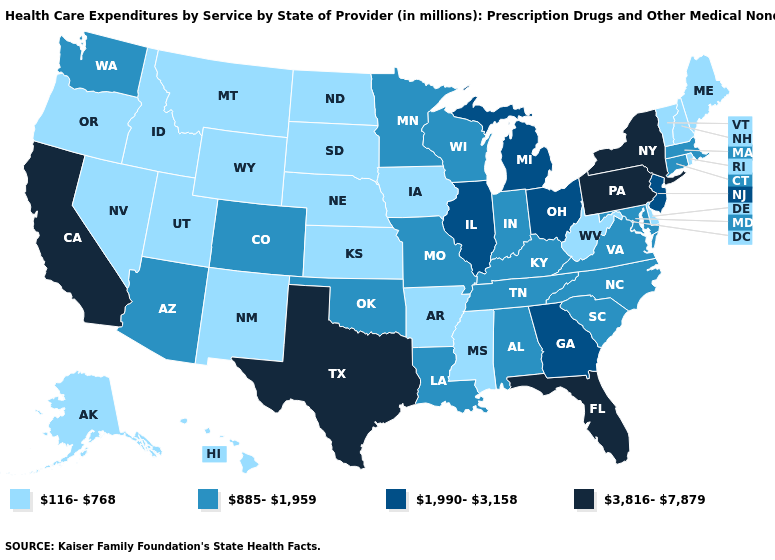What is the value of Connecticut?
Short answer required. 885-1,959. What is the lowest value in the South?
Short answer required. 116-768. Name the states that have a value in the range 116-768?
Answer briefly. Alaska, Arkansas, Delaware, Hawaii, Idaho, Iowa, Kansas, Maine, Mississippi, Montana, Nebraska, Nevada, New Hampshire, New Mexico, North Dakota, Oregon, Rhode Island, South Dakota, Utah, Vermont, West Virginia, Wyoming. Among the states that border Washington , which have the highest value?
Write a very short answer. Idaho, Oregon. Does Ohio have a lower value than California?
Keep it brief. Yes. Which states have the highest value in the USA?
Short answer required. California, Florida, New York, Pennsylvania, Texas. What is the value of Delaware?
Give a very brief answer. 116-768. What is the lowest value in the Northeast?
Concise answer only. 116-768. Is the legend a continuous bar?
Short answer required. No. Name the states that have a value in the range 885-1,959?
Quick response, please. Alabama, Arizona, Colorado, Connecticut, Indiana, Kentucky, Louisiana, Maryland, Massachusetts, Minnesota, Missouri, North Carolina, Oklahoma, South Carolina, Tennessee, Virginia, Washington, Wisconsin. Name the states that have a value in the range 1,990-3,158?
Keep it brief. Georgia, Illinois, Michigan, New Jersey, Ohio. What is the highest value in states that border Texas?
Short answer required. 885-1,959. Name the states that have a value in the range 3,816-7,879?
Concise answer only. California, Florida, New York, Pennsylvania, Texas. What is the value of Mississippi?
Keep it brief. 116-768. 